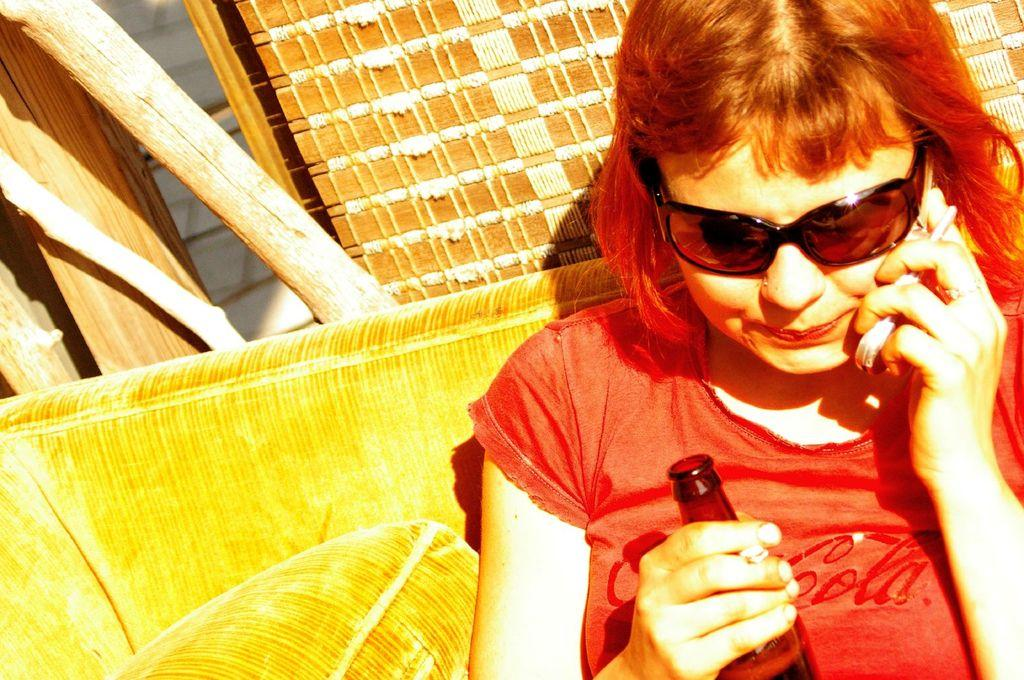What is the woman in the image doing? The woman is sitting in the image and talking on the phone. What is the woman wearing on her face? The woman is wearing sunglasses. What is the woman holding in her hand? The woman is holding a bottle. What can be seen in the background of the image? There are wooden sticks visible in the background of the image. What type of bed is visible in the image? There is no bed present in the image. 